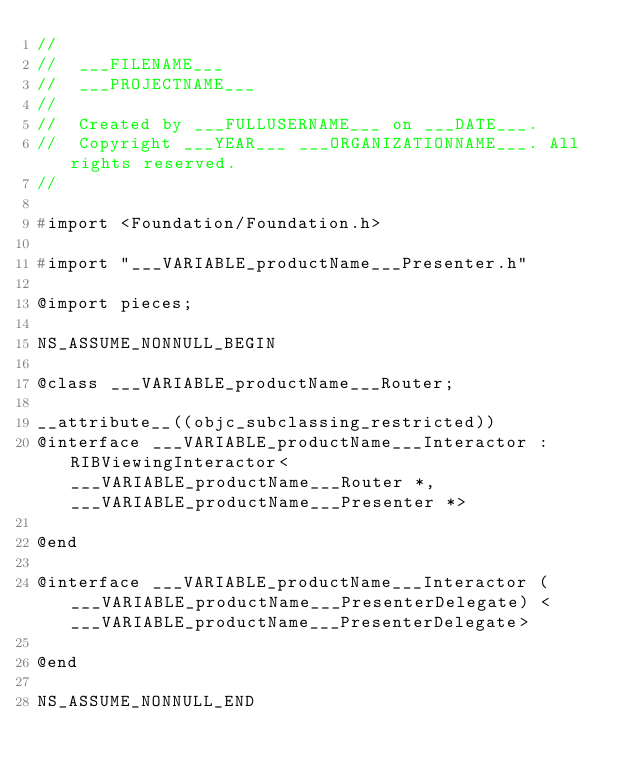<code> <loc_0><loc_0><loc_500><loc_500><_C_>//
//  ___FILENAME___
//  ___PROJECTNAME___
//
//  Created by ___FULLUSERNAME___ on ___DATE___.
//  Copyright ___YEAR___ ___ORGANIZATIONNAME___. All rights reserved.
//

#import <Foundation/Foundation.h>

#import "___VARIABLE_productName___Presenter.h"

@import pieces;

NS_ASSUME_NONNULL_BEGIN

@class ___VARIABLE_productName___Router;

__attribute__((objc_subclassing_restricted))
@interface ___VARIABLE_productName___Interactor : RIBViewingInteractor<___VARIABLE_productName___Router *, ___VARIABLE_productName___Presenter *>

@end

@interface ___VARIABLE_productName___Interactor (___VARIABLE_productName___PresenterDelegate) <___VARIABLE_productName___PresenterDelegate>

@end

NS_ASSUME_NONNULL_END
</code> 